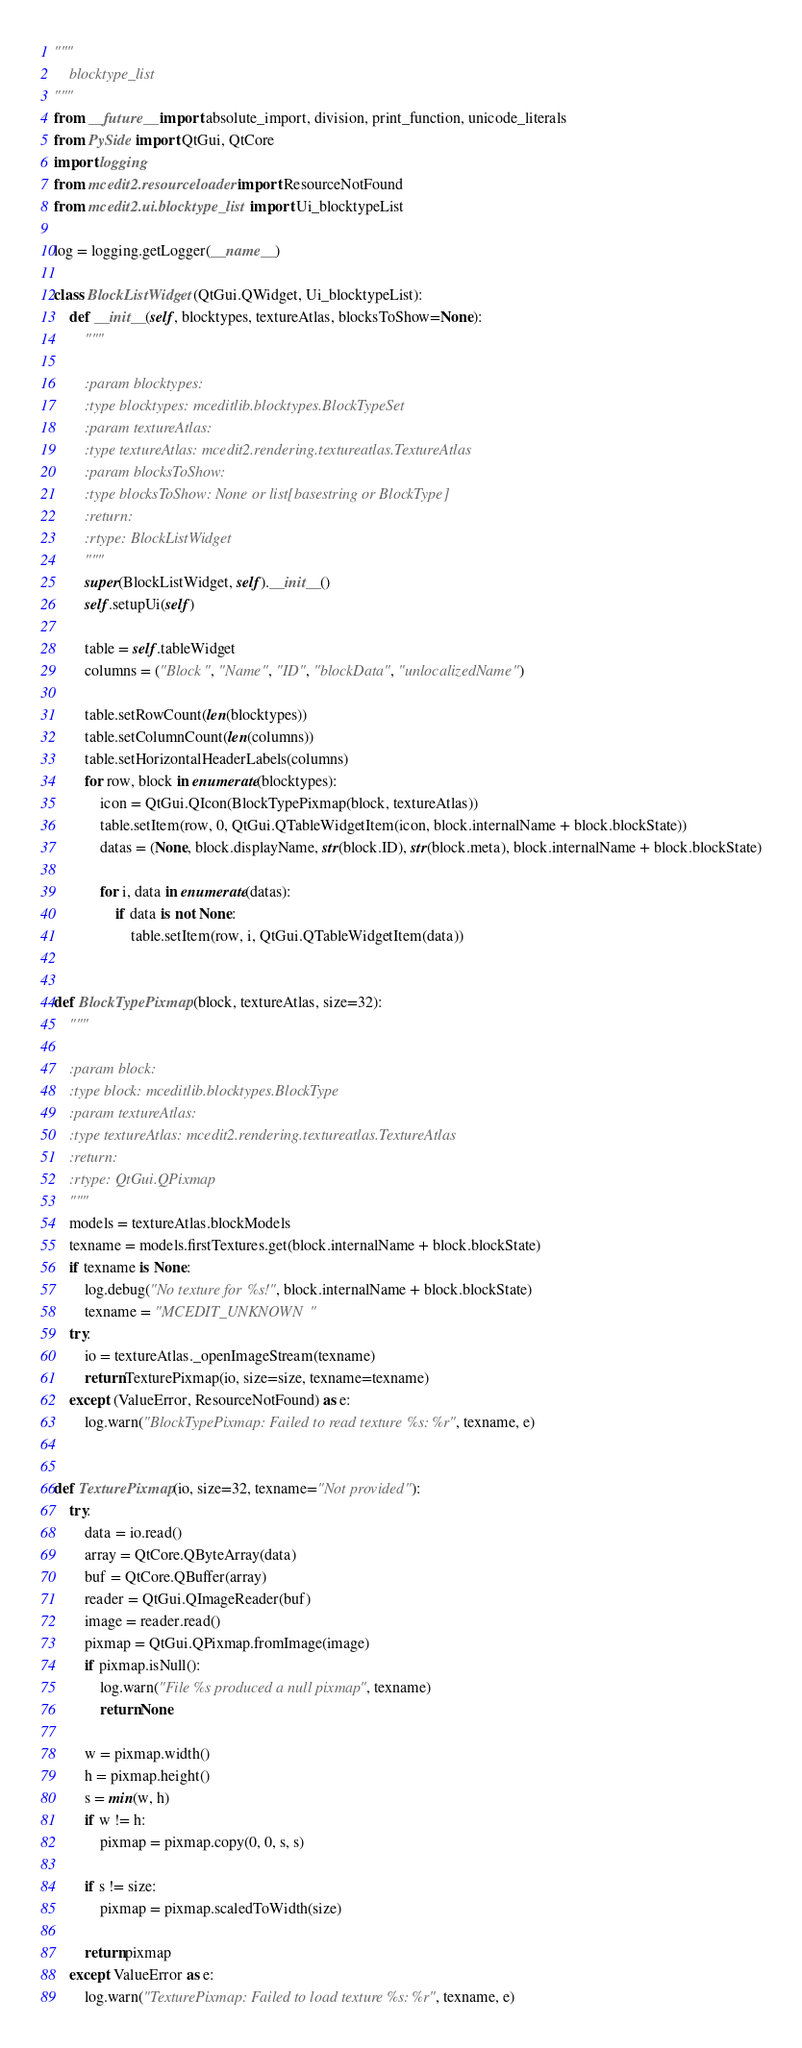Convert code to text. <code><loc_0><loc_0><loc_500><loc_500><_Python_>"""
    blocktype_list
"""
from __future__ import absolute_import, division, print_function, unicode_literals
from PySide import QtGui, QtCore
import logging
from mcedit2.resourceloader import ResourceNotFound
from mcedit2.ui.blocktype_list import Ui_blocktypeList

log = logging.getLogger(__name__)

class BlockListWidget(QtGui.QWidget, Ui_blocktypeList):
    def __init__(self, blocktypes, textureAtlas, blocksToShow=None):
        """

        :param blocktypes:
        :type blocktypes: mceditlib.blocktypes.BlockTypeSet
        :param textureAtlas:
        :type textureAtlas: mcedit2.rendering.textureatlas.TextureAtlas
        :param blocksToShow:
        :type blocksToShow: None or list[basestring or BlockType]
        :return:
        :rtype: BlockListWidget
        """
        super(BlockListWidget, self).__init__()
        self.setupUi(self)

        table = self.tableWidget
        columns = ("Block", "Name", "ID", "blockData", "unlocalizedName")

        table.setRowCount(len(blocktypes))
        table.setColumnCount(len(columns))
        table.setHorizontalHeaderLabels(columns)
        for row, block in enumerate(blocktypes):
            icon = QtGui.QIcon(BlockTypePixmap(block, textureAtlas))
            table.setItem(row, 0, QtGui.QTableWidgetItem(icon, block.internalName + block.blockState))
            datas = (None, block.displayName, str(block.ID), str(block.meta), block.internalName + block.blockState)

            for i, data in enumerate(datas):
                if data is not None:
                    table.setItem(row, i, QtGui.QTableWidgetItem(data))


def BlockTypePixmap(block, textureAtlas, size=32):
    """

    :param block:
    :type block: mceditlib.blocktypes.BlockType
    :param textureAtlas:
    :type textureAtlas: mcedit2.rendering.textureatlas.TextureAtlas
    :return:
    :rtype: QtGui.QPixmap
    """
    models = textureAtlas.blockModels
    texname = models.firstTextures.get(block.internalName + block.blockState)
    if texname is None:
        log.debug("No texture for %s!", block.internalName + block.blockState)
        texname = "MCEDIT_UNKNOWN"
    try:
        io = textureAtlas._openImageStream(texname)
        return TexturePixmap(io, size=size, texname=texname)
    except (ValueError, ResourceNotFound) as e:
        log.warn("BlockTypePixmap: Failed to read texture %s: %r", texname, e)


def TexturePixmap(io, size=32, texname="Not provided"):
    try:
        data = io.read()
        array = QtCore.QByteArray(data)
        buf = QtCore.QBuffer(array)
        reader = QtGui.QImageReader(buf)
        image = reader.read()
        pixmap = QtGui.QPixmap.fromImage(image)
        if pixmap.isNull():
            log.warn("File %s produced a null pixmap", texname)
            return None

        w = pixmap.width()
        h = pixmap.height()
        s = min(w, h)
        if w != h:
            pixmap = pixmap.copy(0, 0, s, s)

        if s != size:
            pixmap = pixmap.scaledToWidth(size)

        return pixmap
    except ValueError as e:
        log.warn("TexturePixmap: Failed to load texture %s: %r", texname, e)
</code> 